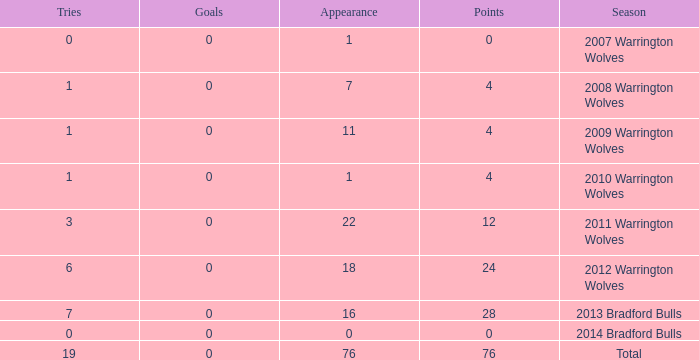How many times is tries 0 and appearance less than 0? 0.0. 